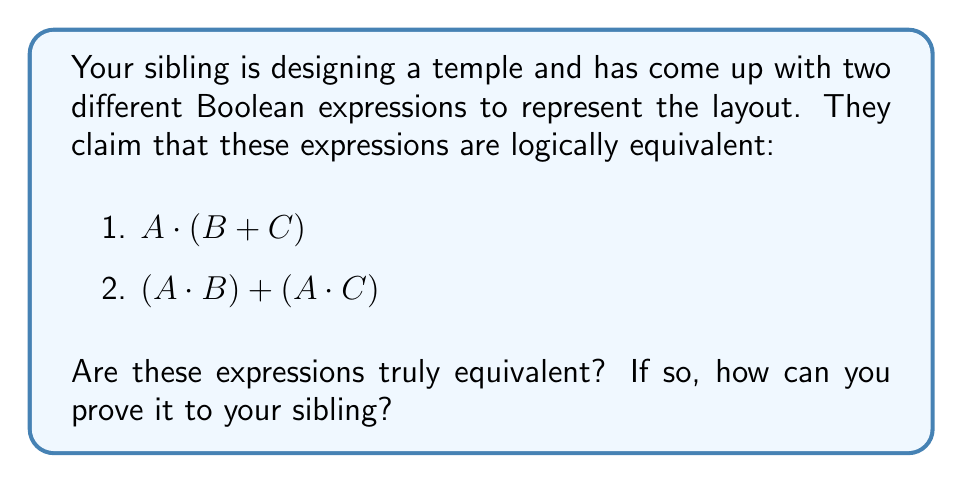Help me with this question. To determine if these expressions are logically equivalent, we can use the distributive property of Boolean algebra. Let's break it down step-by-step:

1. Start with the first expression: $A \cdot (B + C)$

2. Apply the distributive property:
   $A \cdot (B + C) = (A \cdot B) + (A \cdot C)$

3. This results in the second expression: $(A \cdot B) + (A \cdot C)$

4. Since we were able to transform the first expression into the second expression using a valid Boolean algebra property, we can conclude that these expressions are logically equivalent.

To further illustrate this, we can create a truth table:

$$
\begin{array}{|c|c|c|c|c|}
\hline
A & B & C & A \cdot (B + C) & (A \cdot B) + (A \cdot C) \\
\hline
0 & 0 & 0 & 0 & 0 \\
0 & 0 & 1 & 0 & 0 \\
0 & 1 & 0 & 0 & 0 \\
0 & 1 & 1 & 0 & 0 \\
1 & 0 & 0 & 0 & 0 \\
1 & 0 & 1 & 1 & 1 \\
1 & 1 & 0 & 1 & 1 \\
1 & 1 & 1 & 1 & 1 \\
\hline
\end{array}
$$

As we can see, the output columns for both expressions are identical, further proving their logical equivalence.
Answer: Yes, equivalent. Proof: $A \cdot (B + C) = (A \cdot B) + (A \cdot C)$ by distributive property. 